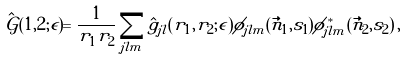Convert formula to latex. <formula><loc_0><loc_0><loc_500><loc_500>\hat { \mathcal { G } } ( 1 , 2 ; \epsilon ) = \frac { 1 } { r _ { 1 } r _ { 2 } } \sum _ { j l m } \hat { g } _ { j l } ( r _ { 1 } , r _ { 2 } ; \epsilon ) \phi _ { j l m } ( \vec { n } _ { 1 } , s _ { 1 } ) \phi ^ { * } _ { j l m } ( \vec { n } _ { 2 } , s _ { 2 } ) \, ,</formula> 